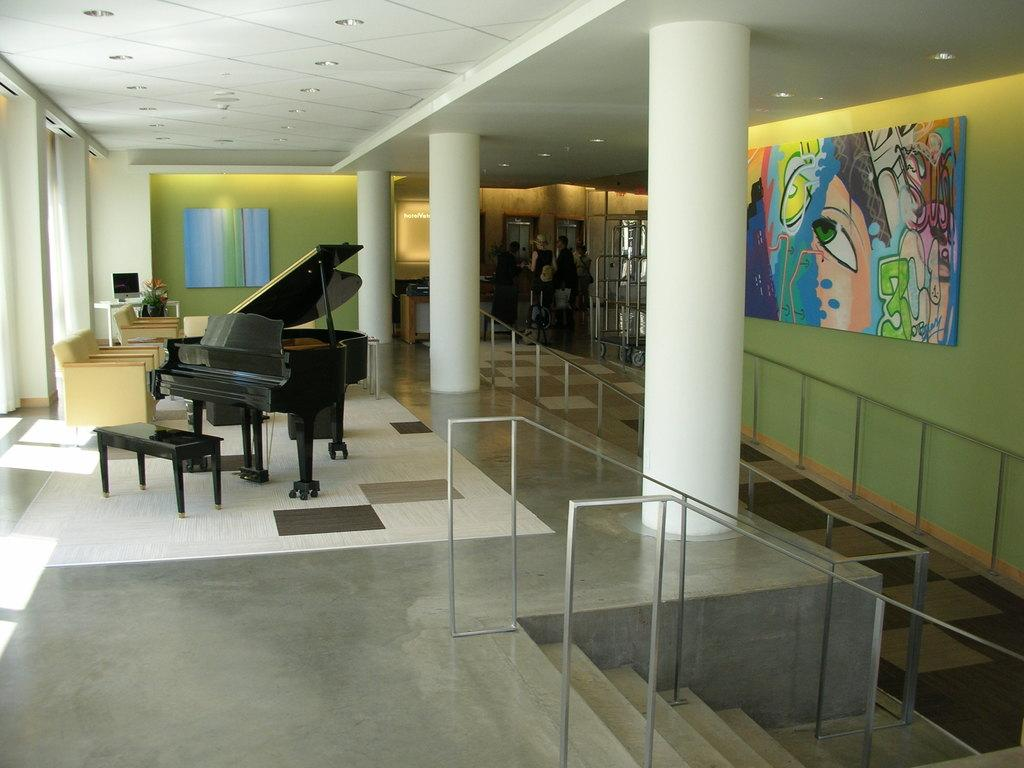What is the main object in the middle of the room? There is a piano in the middle of the room. What other objects are in the middle of the room? There are pillars in the middle of the room. What type of seating is available in the room? There are sofa chairs in the room. What decorative elements can be found on the walls? There are wall paintings in the room. What is the tendency of the piano to walk around the room? The piano does not have a tendency to walk around the room; it is a stationary object. 